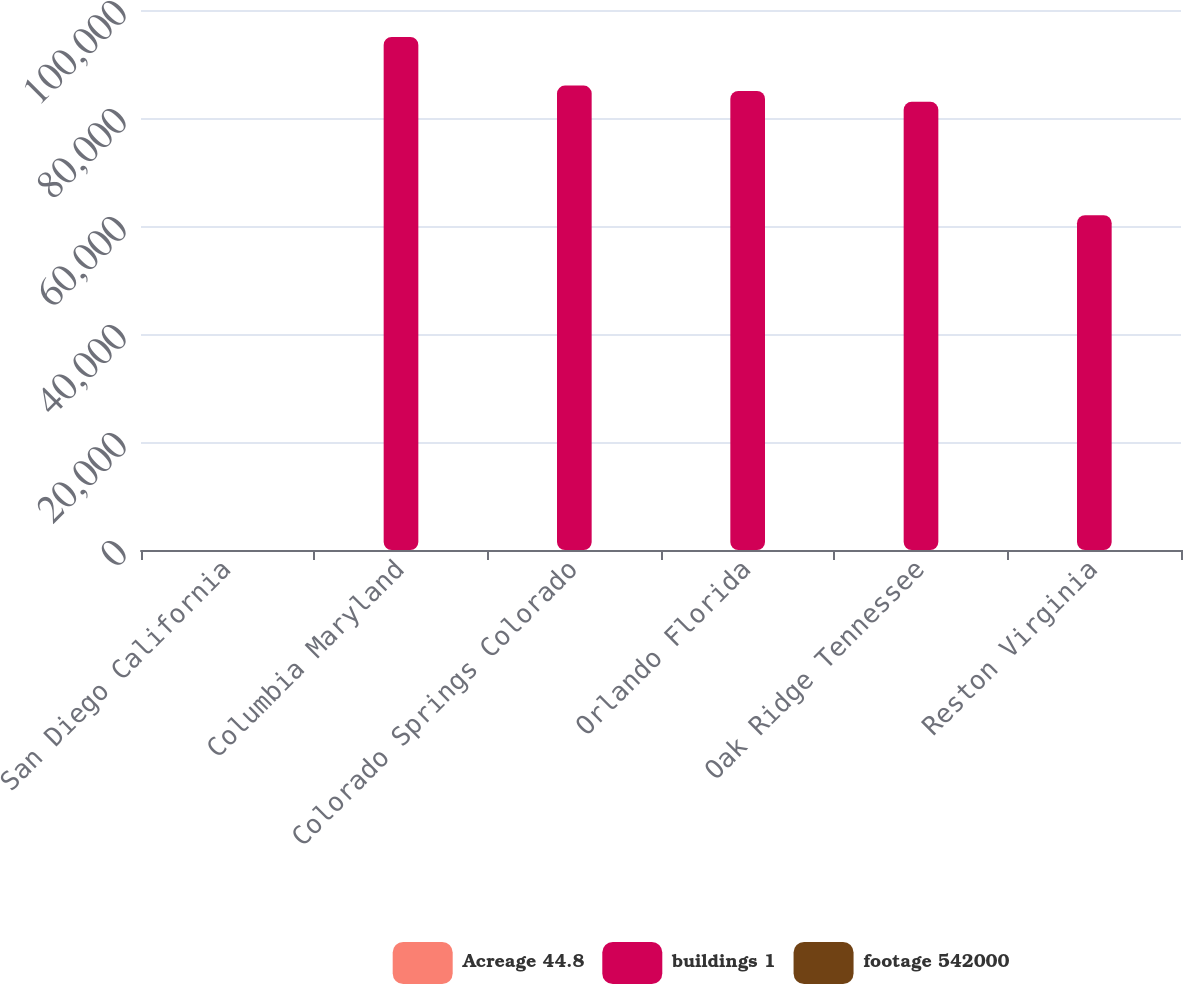<chart> <loc_0><loc_0><loc_500><loc_500><stacked_bar_chart><ecel><fcel>San Diego California<fcel>Columbia Maryland<fcel>Colorado Springs Colorado<fcel>Orlando Florida<fcel>Oak Ridge Tennessee<fcel>Reston Virginia<nl><fcel>Acreage 44.8<fcel>2<fcel>1<fcel>1<fcel>1<fcel>1<fcel>1<nl><fcel>buildings 1<fcel>8.4<fcel>95000<fcel>86000<fcel>85000<fcel>83000<fcel>62000<nl><fcel>footage 542000<fcel>13.5<fcel>7.3<fcel>14.2<fcel>8.5<fcel>8.4<fcel>2.6<nl></chart> 